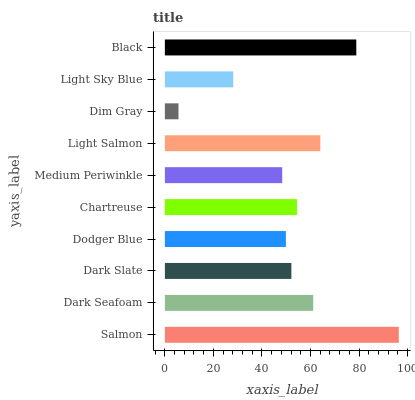Is Dim Gray the minimum?
Answer yes or no. Yes. Is Salmon the maximum?
Answer yes or no. Yes. Is Dark Seafoam the minimum?
Answer yes or no. No. Is Dark Seafoam the maximum?
Answer yes or no. No. Is Salmon greater than Dark Seafoam?
Answer yes or no. Yes. Is Dark Seafoam less than Salmon?
Answer yes or no. Yes. Is Dark Seafoam greater than Salmon?
Answer yes or no. No. Is Salmon less than Dark Seafoam?
Answer yes or no. No. Is Chartreuse the high median?
Answer yes or no. Yes. Is Dark Slate the low median?
Answer yes or no. Yes. Is Salmon the high median?
Answer yes or no. No. Is Salmon the low median?
Answer yes or no. No. 